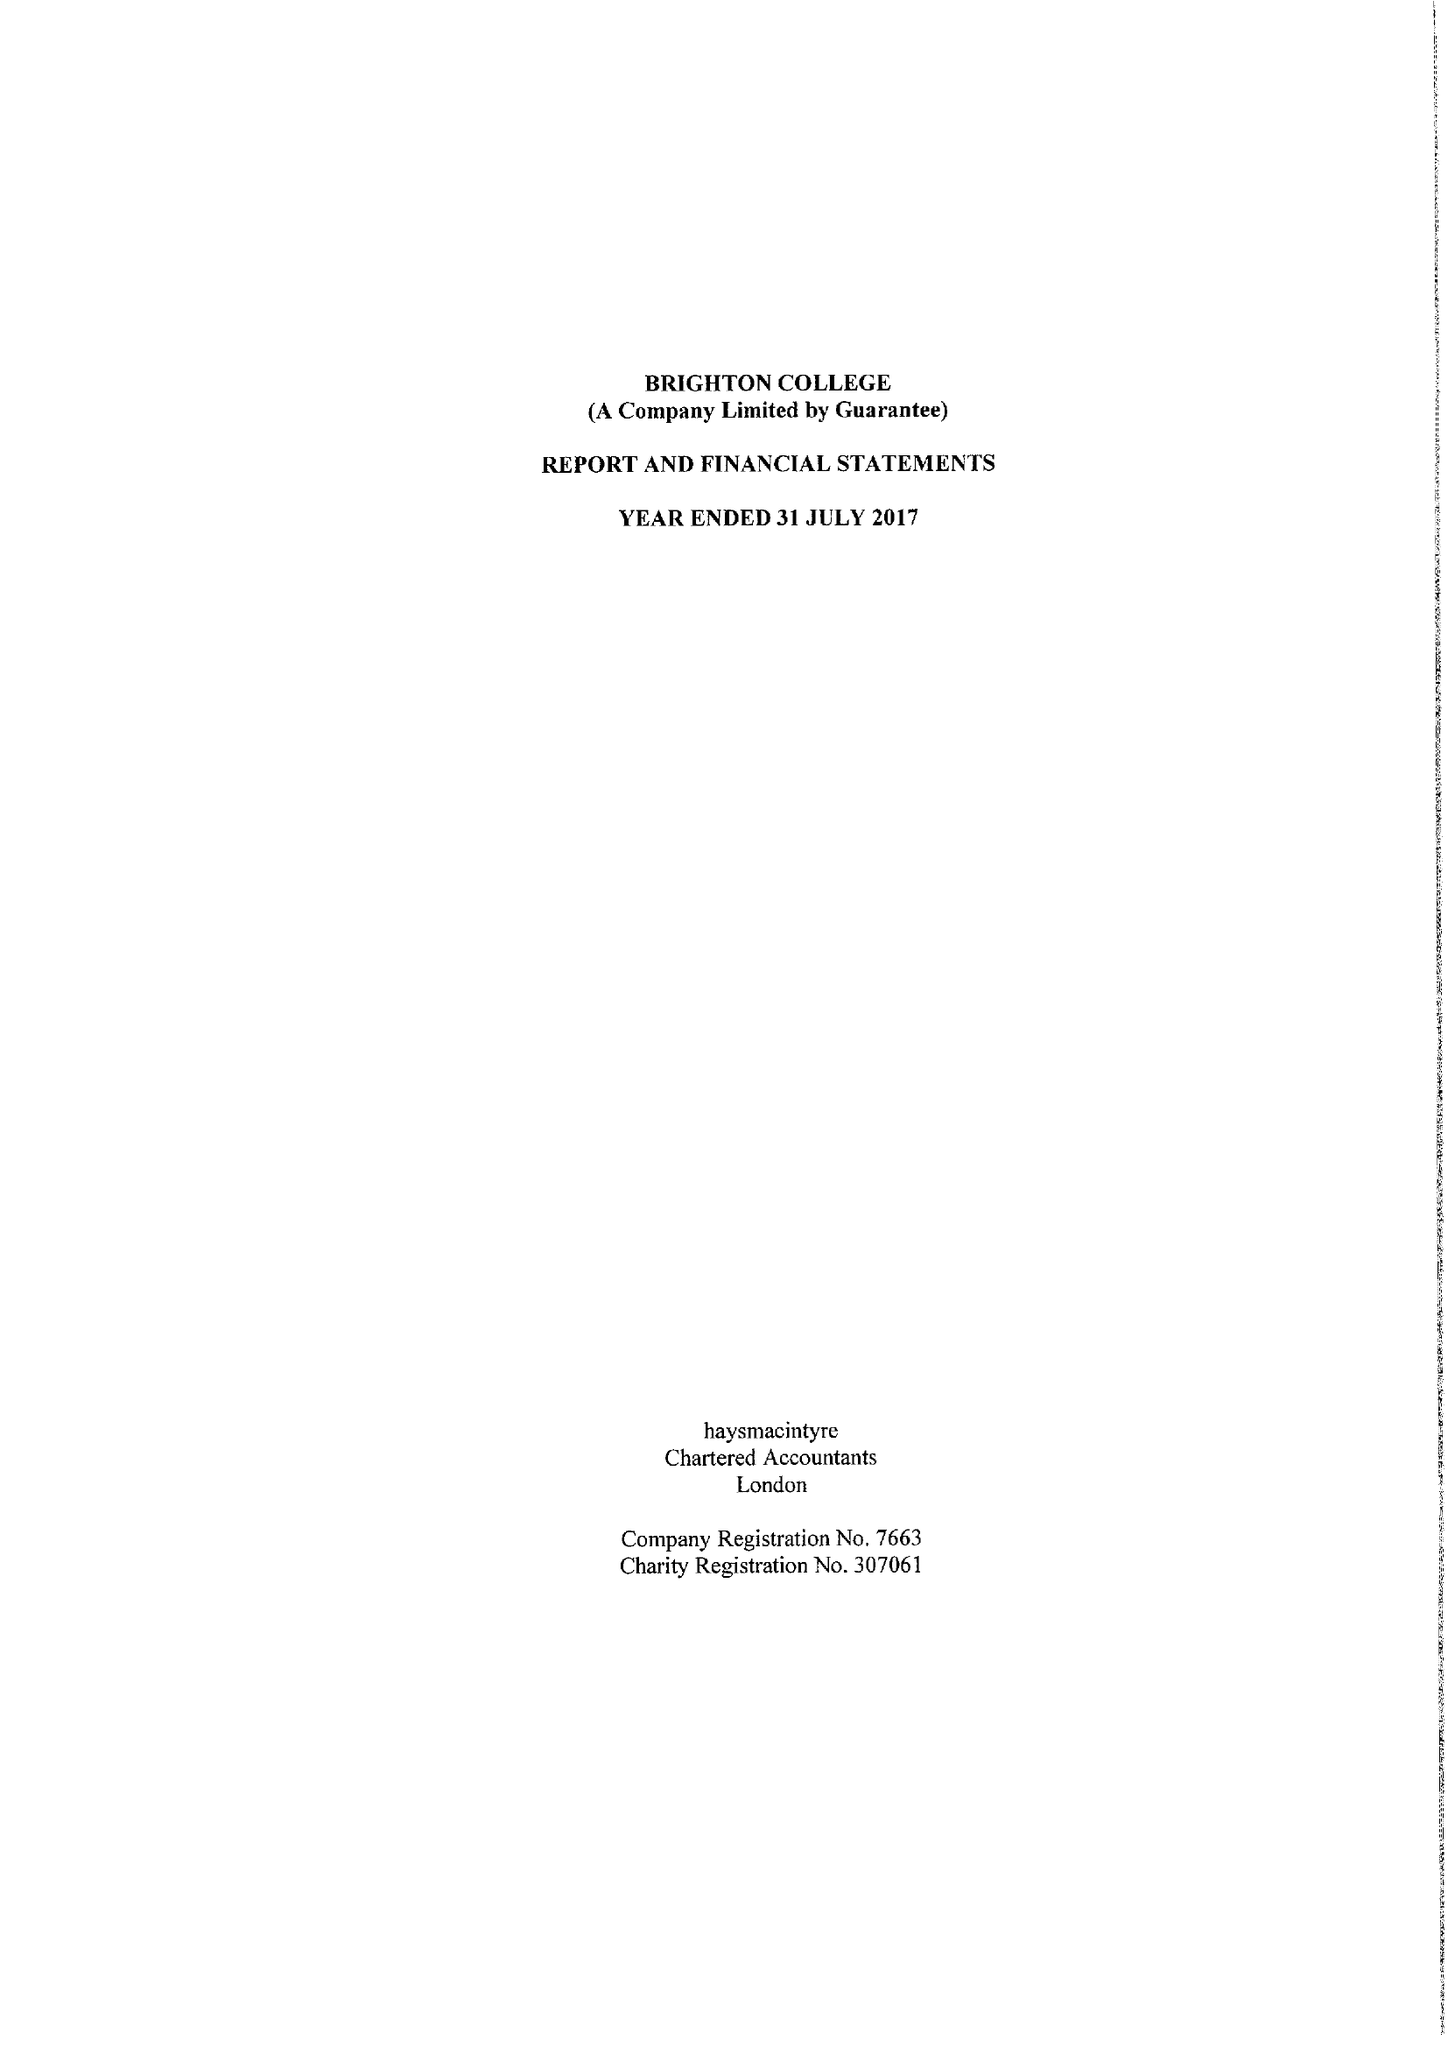What is the value for the spending_annually_in_british_pounds?
Answer the question using a single word or phrase. 36795936.00 